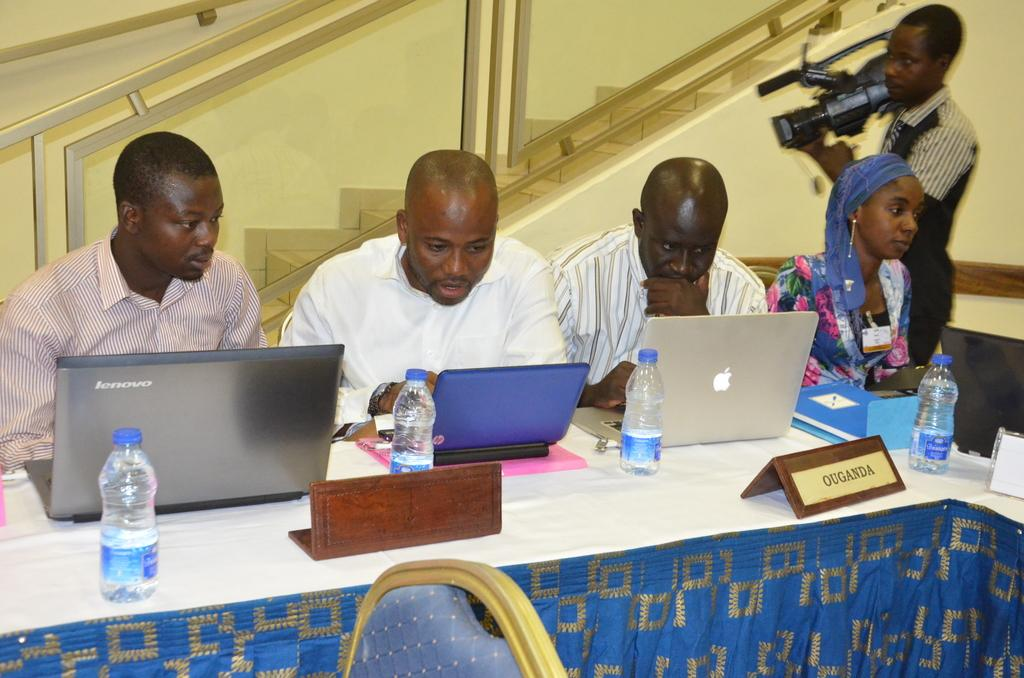<image>
Relay a brief, clear account of the picture shown. A group of men and one woman are using laptops at a table that says Ouganda. 